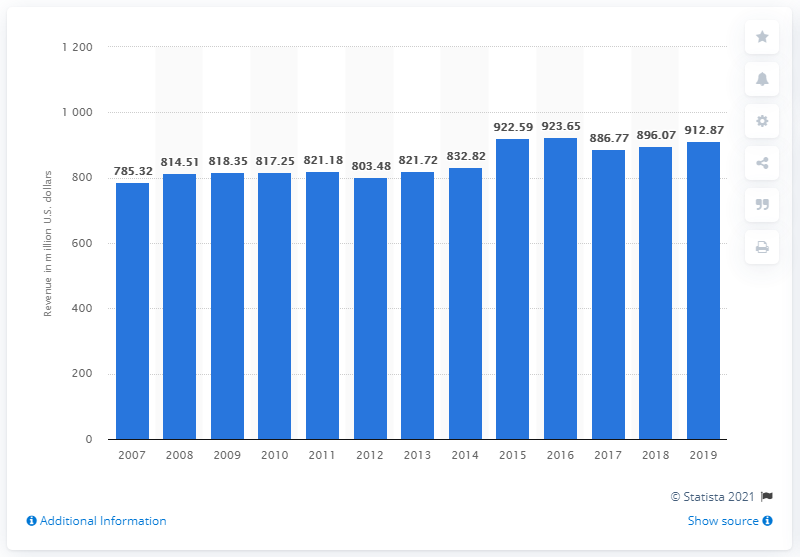Specify some key components in this picture. In 2019, Chuck E. Cheese generated approximately $912.87 in revenue. In the previous year, Chuck E. Cheese's revenue was 896.07. 